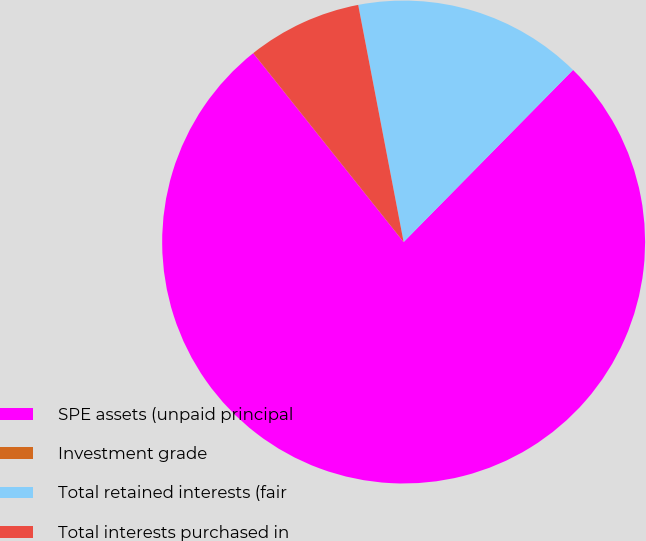Convert chart. <chart><loc_0><loc_0><loc_500><loc_500><pie_chart><fcel>SPE assets (unpaid principal<fcel>Investment grade<fcel>Total retained interests (fair<fcel>Total interests purchased in<nl><fcel>76.92%<fcel>0.0%<fcel>15.39%<fcel>7.69%<nl></chart> 